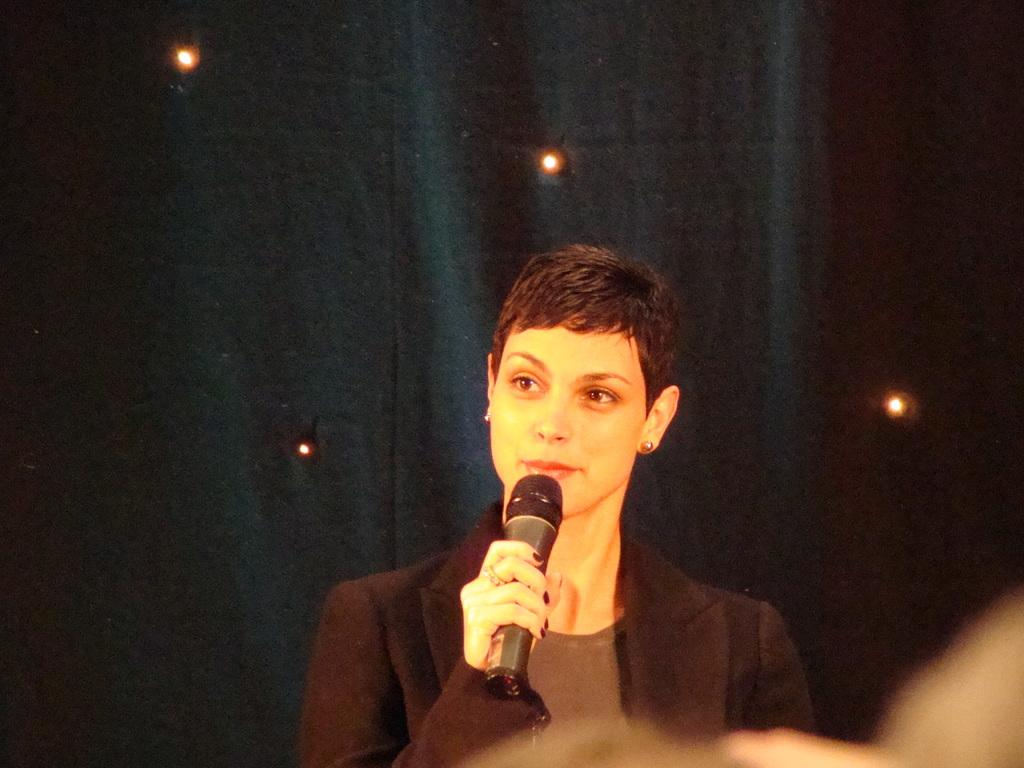What is the person holding in the image? The person is holding a microphone. What is the person wearing in the image? The person is wearing a suit. What can be seen in the background of the image? There are lights and a curtain in the background. What type of jam is being served on the plate in the image? There is no plate or jam present in the image. How does the frame of the microphone taste in the image? The microphone does not have a taste, as it is an inanimate object and not edible. 